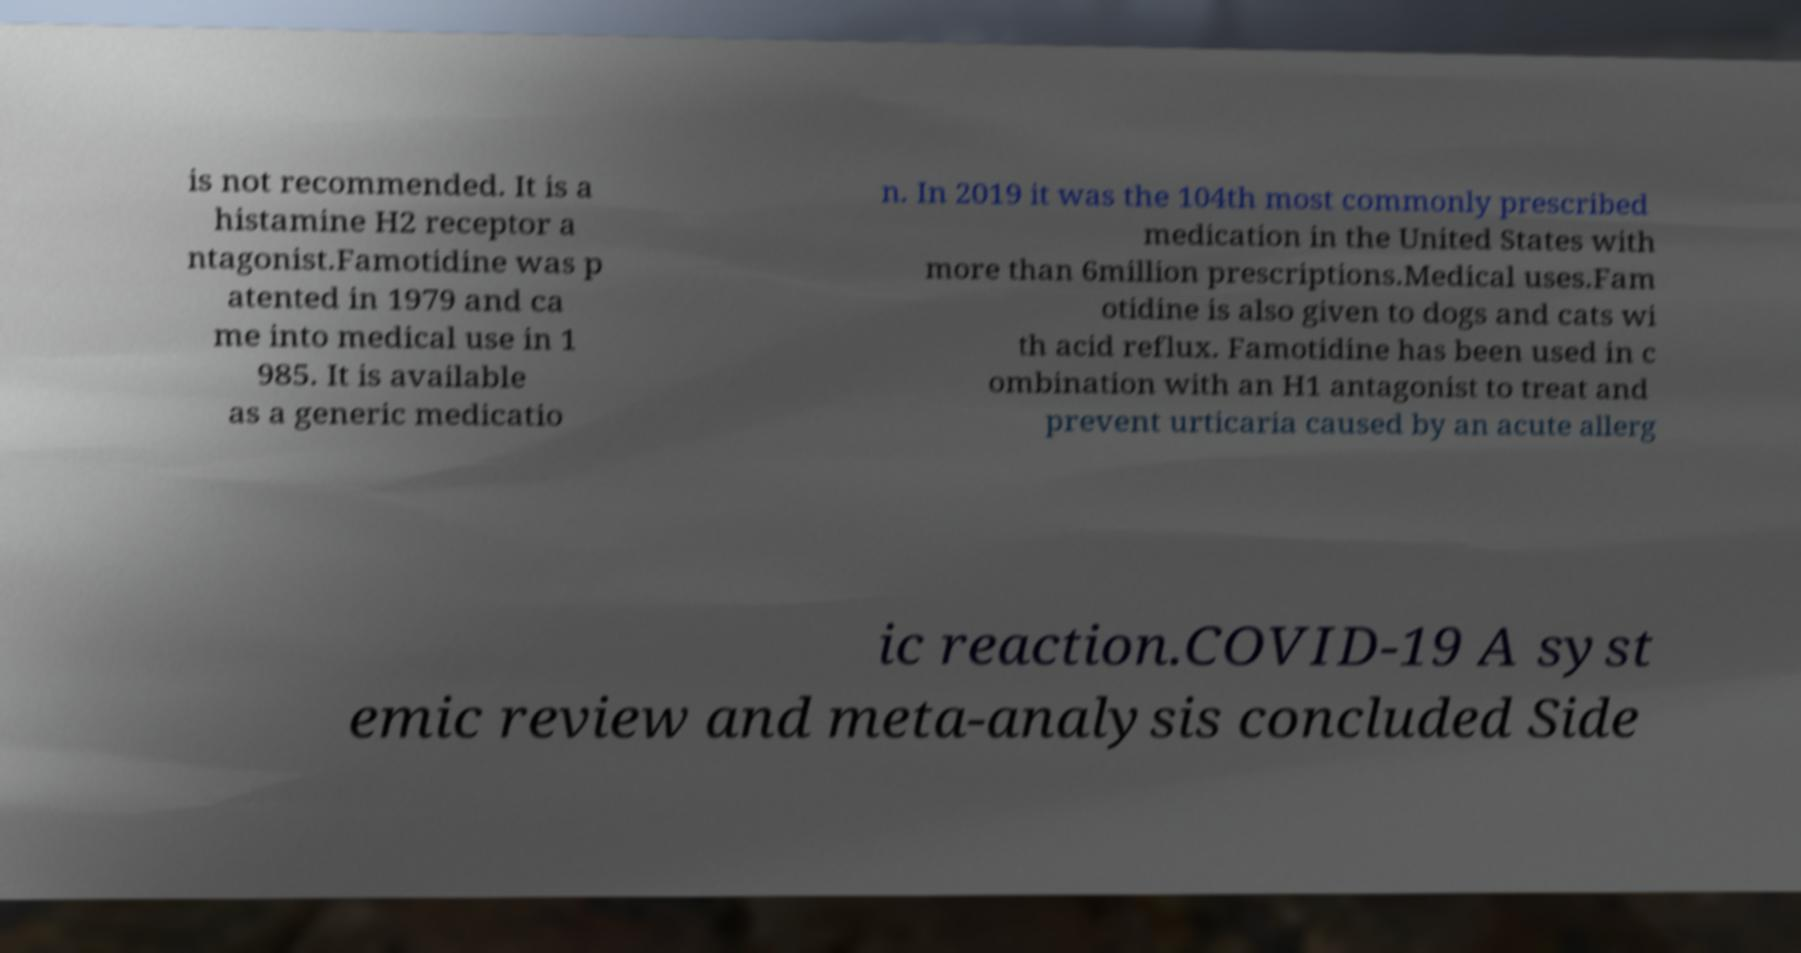Can you read and provide the text displayed in the image?This photo seems to have some interesting text. Can you extract and type it out for me? is not recommended. It is a histamine H2 receptor a ntagonist.Famotidine was p atented in 1979 and ca me into medical use in 1 985. It is available as a generic medicatio n. In 2019 it was the 104th most commonly prescribed medication in the United States with more than 6million prescriptions.Medical uses.Fam otidine is also given to dogs and cats wi th acid reflux. Famotidine has been used in c ombination with an H1 antagonist to treat and prevent urticaria caused by an acute allerg ic reaction.COVID-19 A syst emic review and meta-analysis concluded Side 